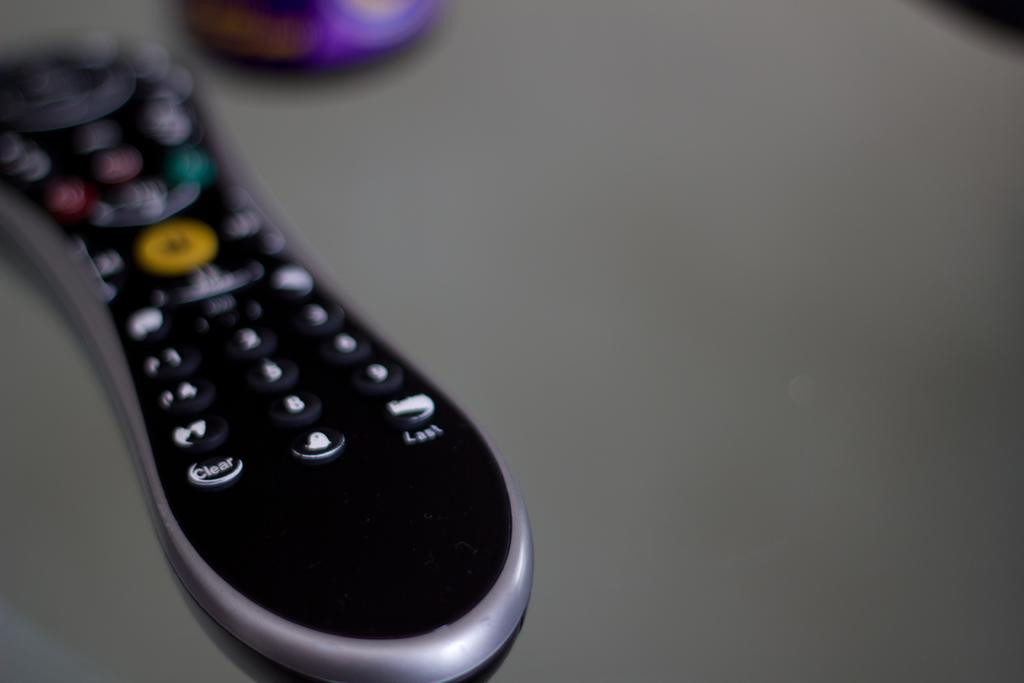<image>
Present a compact description of the photo's key features. Black remote controller with the "Clear" button on the bottom left. 